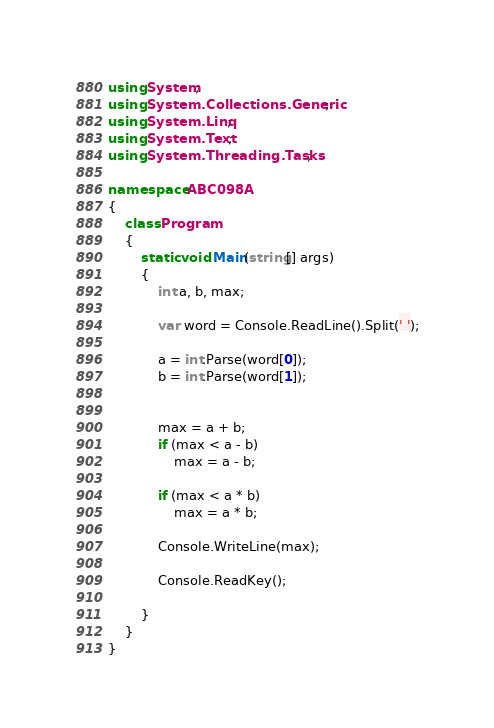Convert code to text. <code><loc_0><loc_0><loc_500><loc_500><_C#_>using System;
using System.Collections.Generic;
using System.Linq;
using System.Text;
using System.Threading.Tasks;

namespace ABC098A
{
	class Program
	{
		static void Main(string[] args)
		{
			int a, b, max;

			var word = Console.ReadLine().Split(' ');

			a = int.Parse(word[0]);
			b = int.Parse(word[1]);


			max = a + b;
			if (max < a - b)
				max = a - b;

			if (max < a * b)
				max = a * b;

			Console.WriteLine(max);

			Console.ReadKey();

		}
	}
}
</code> 